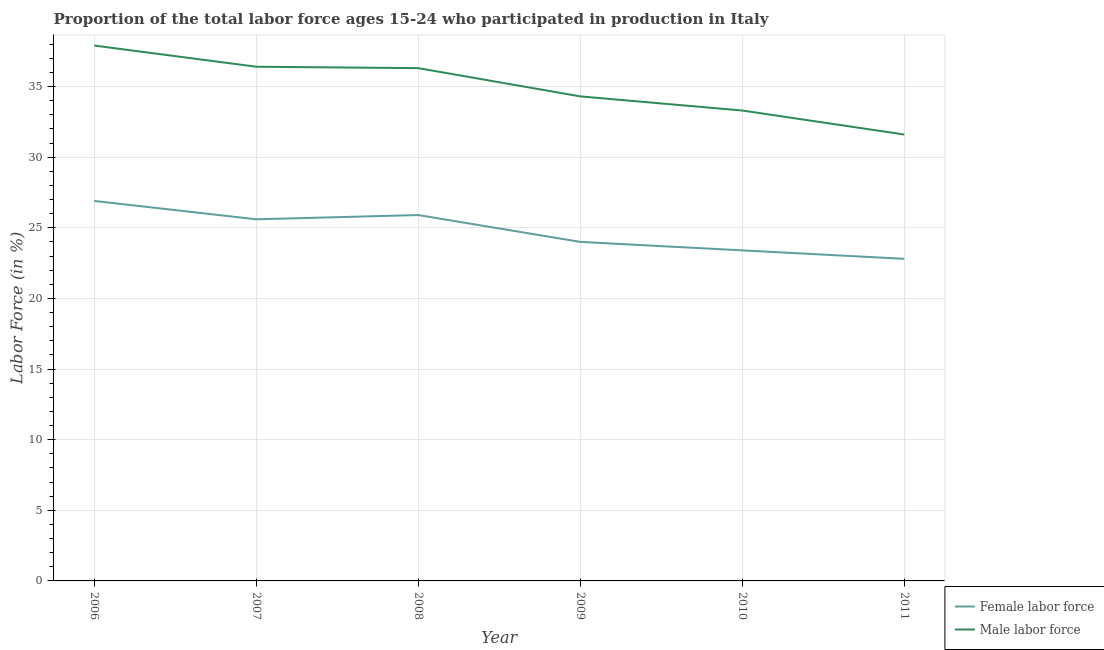How many different coloured lines are there?
Ensure brevity in your answer.  2. Is the number of lines equal to the number of legend labels?
Ensure brevity in your answer.  Yes. What is the percentage of male labour force in 2008?
Your answer should be very brief. 36.3. Across all years, what is the maximum percentage of male labour force?
Keep it short and to the point. 37.9. Across all years, what is the minimum percentage of male labour force?
Give a very brief answer. 31.6. In which year was the percentage of male labour force maximum?
Ensure brevity in your answer.  2006. In which year was the percentage of male labour force minimum?
Offer a very short reply. 2011. What is the total percentage of male labour force in the graph?
Ensure brevity in your answer.  209.8. What is the difference between the percentage of male labour force in 2009 and that in 2011?
Give a very brief answer. 2.7. What is the difference between the percentage of female labor force in 2007 and the percentage of male labour force in 2011?
Ensure brevity in your answer.  -6. What is the average percentage of male labour force per year?
Provide a succinct answer. 34.97. In the year 2011, what is the difference between the percentage of male labour force and percentage of female labor force?
Provide a short and direct response. 8.8. What is the ratio of the percentage of male labour force in 2007 to that in 2011?
Make the answer very short. 1.15. Is the percentage of male labour force in 2009 less than that in 2010?
Keep it short and to the point. No. What is the difference between the highest and the lowest percentage of male labour force?
Your response must be concise. 6.3. In how many years, is the percentage of male labour force greater than the average percentage of male labour force taken over all years?
Make the answer very short. 3. How many lines are there?
Give a very brief answer. 2. How many years are there in the graph?
Your answer should be compact. 6. Where does the legend appear in the graph?
Give a very brief answer. Bottom right. How many legend labels are there?
Offer a very short reply. 2. How are the legend labels stacked?
Provide a short and direct response. Vertical. What is the title of the graph?
Give a very brief answer. Proportion of the total labor force ages 15-24 who participated in production in Italy. Does "Non-residents" appear as one of the legend labels in the graph?
Provide a succinct answer. No. What is the label or title of the X-axis?
Provide a succinct answer. Year. What is the label or title of the Y-axis?
Offer a terse response. Labor Force (in %). What is the Labor Force (in %) in Female labor force in 2006?
Give a very brief answer. 26.9. What is the Labor Force (in %) of Male labor force in 2006?
Keep it short and to the point. 37.9. What is the Labor Force (in %) in Female labor force in 2007?
Make the answer very short. 25.6. What is the Labor Force (in %) of Male labor force in 2007?
Your response must be concise. 36.4. What is the Labor Force (in %) in Female labor force in 2008?
Make the answer very short. 25.9. What is the Labor Force (in %) of Male labor force in 2008?
Offer a very short reply. 36.3. What is the Labor Force (in %) of Male labor force in 2009?
Make the answer very short. 34.3. What is the Labor Force (in %) of Female labor force in 2010?
Keep it short and to the point. 23.4. What is the Labor Force (in %) of Male labor force in 2010?
Offer a terse response. 33.3. What is the Labor Force (in %) of Female labor force in 2011?
Your answer should be very brief. 22.8. What is the Labor Force (in %) of Male labor force in 2011?
Provide a succinct answer. 31.6. Across all years, what is the maximum Labor Force (in %) of Female labor force?
Make the answer very short. 26.9. Across all years, what is the maximum Labor Force (in %) in Male labor force?
Your answer should be very brief. 37.9. Across all years, what is the minimum Labor Force (in %) in Female labor force?
Give a very brief answer. 22.8. Across all years, what is the minimum Labor Force (in %) of Male labor force?
Offer a very short reply. 31.6. What is the total Labor Force (in %) of Female labor force in the graph?
Offer a terse response. 148.6. What is the total Labor Force (in %) in Male labor force in the graph?
Ensure brevity in your answer.  209.8. What is the difference between the Labor Force (in %) of Female labor force in 2006 and that in 2007?
Offer a terse response. 1.3. What is the difference between the Labor Force (in %) of Male labor force in 2006 and that in 2007?
Your response must be concise. 1.5. What is the difference between the Labor Force (in %) of Female labor force in 2006 and that in 2008?
Ensure brevity in your answer.  1. What is the difference between the Labor Force (in %) of Male labor force in 2006 and that in 2008?
Offer a very short reply. 1.6. What is the difference between the Labor Force (in %) of Female labor force in 2006 and that in 2009?
Ensure brevity in your answer.  2.9. What is the difference between the Labor Force (in %) of Male labor force in 2006 and that in 2009?
Ensure brevity in your answer.  3.6. What is the difference between the Labor Force (in %) of Female labor force in 2006 and that in 2011?
Make the answer very short. 4.1. What is the difference between the Labor Force (in %) in Male labor force in 2006 and that in 2011?
Provide a short and direct response. 6.3. What is the difference between the Labor Force (in %) of Female labor force in 2007 and that in 2008?
Provide a succinct answer. -0.3. What is the difference between the Labor Force (in %) of Male labor force in 2007 and that in 2008?
Your answer should be very brief. 0.1. What is the difference between the Labor Force (in %) in Female labor force in 2007 and that in 2009?
Offer a very short reply. 1.6. What is the difference between the Labor Force (in %) in Female labor force in 2007 and that in 2010?
Your answer should be very brief. 2.2. What is the difference between the Labor Force (in %) of Male labor force in 2007 and that in 2011?
Your answer should be compact. 4.8. What is the difference between the Labor Force (in %) of Female labor force in 2008 and that in 2009?
Provide a succinct answer. 1.9. What is the difference between the Labor Force (in %) in Male labor force in 2008 and that in 2009?
Your answer should be compact. 2. What is the difference between the Labor Force (in %) in Female labor force in 2008 and that in 2010?
Give a very brief answer. 2.5. What is the difference between the Labor Force (in %) in Male labor force in 2008 and that in 2010?
Your answer should be compact. 3. What is the difference between the Labor Force (in %) of Male labor force in 2008 and that in 2011?
Offer a terse response. 4.7. What is the difference between the Labor Force (in %) in Female labor force in 2009 and that in 2010?
Your answer should be compact. 0.6. What is the difference between the Labor Force (in %) of Male labor force in 2009 and that in 2010?
Ensure brevity in your answer.  1. What is the difference between the Labor Force (in %) in Female labor force in 2010 and that in 2011?
Offer a terse response. 0.6. What is the difference between the Labor Force (in %) in Female labor force in 2006 and the Labor Force (in %) in Male labor force in 2007?
Your response must be concise. -9.5. What is the difference between the Labor Force (in %) of Female labor force in 2007 and the Labor Force (in %) of Male labor force in 2008?
Your response must be concise. -10.7. What is the difference between the Labor Force (in %) in Female labor force in 2007 and the Labor Force (in %) in Male labor force in 2009?
Provide a short and direct response. -8.7. What is the difference between the Labor Force (in %) of Female labor force in 2007 and the Labor Force (in %) of Male labor force in 2011?
Your answer should be very brief. -6. What is the difference between the Labor Force (in %) of Female labor force in 2008 and the Labor Force (in %) of Male labor force in 2009?
Offer a very short reply. -8.4. What is the difference between the Labor Force (in %) in Female labor force in 2009 and the Labor Force (in %) in Male labor force in 2011?
Your answer should be very brief. -7.6. What is the average Labor Force (in %) in Female labor force per year?
Your response must be concise. 24.77. What is the average Labor Force (in %) of Male labor force per year?
Your answer should be very brief. 34.97. In the year 2007, what is the difference between the Labor Force (in %) of Female labor force and Labor Force (in %) of Male labor force?
Give a very brief answer. -10.8. In the year 2010, what is the difference between the Labor Force (in %) of Female labor force and Labor Force (in %) of Male labor force?
Provide a succinct answer. -9.9. What is the ratio of the Labor Force (in %) in Female labor force in 2006 to that in 2007?
Ensure brevity in your answer.  1.05. What is the ratio of the Labor Force (in %) in Male labor force in 2006 to that in 2007?
Your answer should be compact. 1.04. What is the ratio of the Labor Force (in %) of Female labor force in 2006 to that in 2008?
Give a very brief answer. 1.04. What is the ratio of the Labor Force (in %) of Male labor force in 2006 to that in 2008?
Your response must be concise. 1.04. What is the ratio of the Labor Force (in %) in Female labor force in 2006 to that in 2009?
Ensure brevity in your answer.  1.12. What is the ratio of the Labor Force (in %) of Male labor force in 2006 to that in 2009?
Provide a short and direct response. 1.1. What is the ratio of the Labor Force (in %) in Female labor force in 2006 to that in 2010?
Provide a short and direct response. 1.15. What is the ratio of the Labor Force (in %) of Male labor force in 2006 to that in 2010?
Provide a short and direct response. 1.14. What is the ratio of the Labor Force (in %) of Female labor force in 2006 to that in 2011?
Offer a very short reply. 1.18. What is the ratio of the Labor Force (in %) in Male labor force in 2006 to that in 2011?
Your response must be concise. 1.2. What is the ratio of the Labor Force (in %) of Female labor force in 2007 to that in 2008?
Keep it short and to the point. 0.99. What is the ratio of the Labor Force (in %) of Male labor force in 2007 to that in 2008?
Provide a short and direct response. 1. What is the ratio of the Labor Force (in %) in Female labor force in 2007 to that in 2009?
Your answer should be compact. 1.07. What is the ratio of the Labor Force (in %) of Male labor force in 2007 to that in 2009?
Your response must be concise. 1.06. What is the ratio of the Labor Force (in %) in Female labor force in 2007 to that in 2010?
Your answer should be compact. 1.09. What is the ratio of the Labor Force (in %) of Male labor force in 2007 to that in 2010?
Your response must be concise. 1.09. What is the ratio of the Labor Force (in %) of Female labor force in 2007 to that in 2011?
Keep it short and to the point. 1.12. What is the ratio of the Labor Force (in %) in Male labor force in 2007 to that in 2011?
Provide a succinct answer. 1.15. What is the ratio of the Labor Force (in %) in Female labor force in 2008 to that in 2009?
Your response must be concise. 1.08. What is the ratio of the Labor Force (in %) in Male labor force in 2008 to that in 2009?
Offer a terse response. 1.06. What is the ratio of the Labor Force (in %) of Female labor force in 2008 to that in 2010?
Your response must be concise. 1.11. What is the ratio of the Labor Force (in %) in Male labor force in 2008 to that in 2010?
Provide a succinct answer. 1.09. What is the ratio of the Labor Force (in %) in Female labor force in 2008 to that in 2011?
Ensure brevity in your answer.  1.14. What is the ratio of the Labor Force (in %) in Male labor force in 2008 to that in 2011?
Keep it short and to the point. 1.15. What is the ratio of the Labor Force (in %) of Female labor force in 2009 to that in 2010?
Your answer should be very brief. 1.03. What is the ratio of the Labor Force (in %) in Female labor force in 2009 to that in 2011?
Give a very brief answer. 1.05. What is the ratio of the Labor Force (in %) in Male labor force in 2009 to that in 2011?
Your answer should be very brief. 1.09. What is the ratio of the Labor Force (in %) in Female labor force in 2010 to that in 2011?
Make the answer very short. 1.03. What is the ratio of the Labor Force (in %) in Male labor force in 2010 to that in 2011?
Your answer should be very brief. 1.05. 